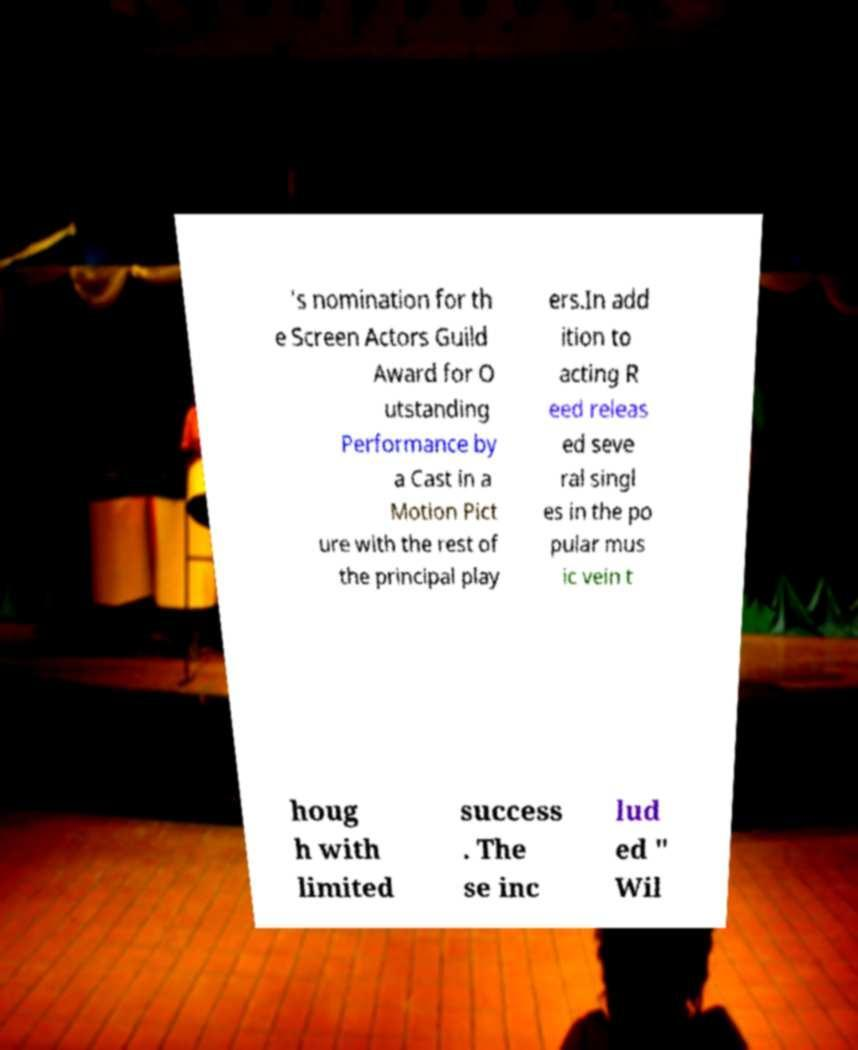Could you assist in decoding the text presented in this image and type it out clearly? 's nomination for th e Screen Actors Guild Award for O utstanding Performance by a Cast in a Motion Pict ure with the rest of the principal play ers.In add ition to acting R eed releas ed seve ral singl es in the po pular mus ic vein t houg h with limited success . The se inc lud ed " Wil 